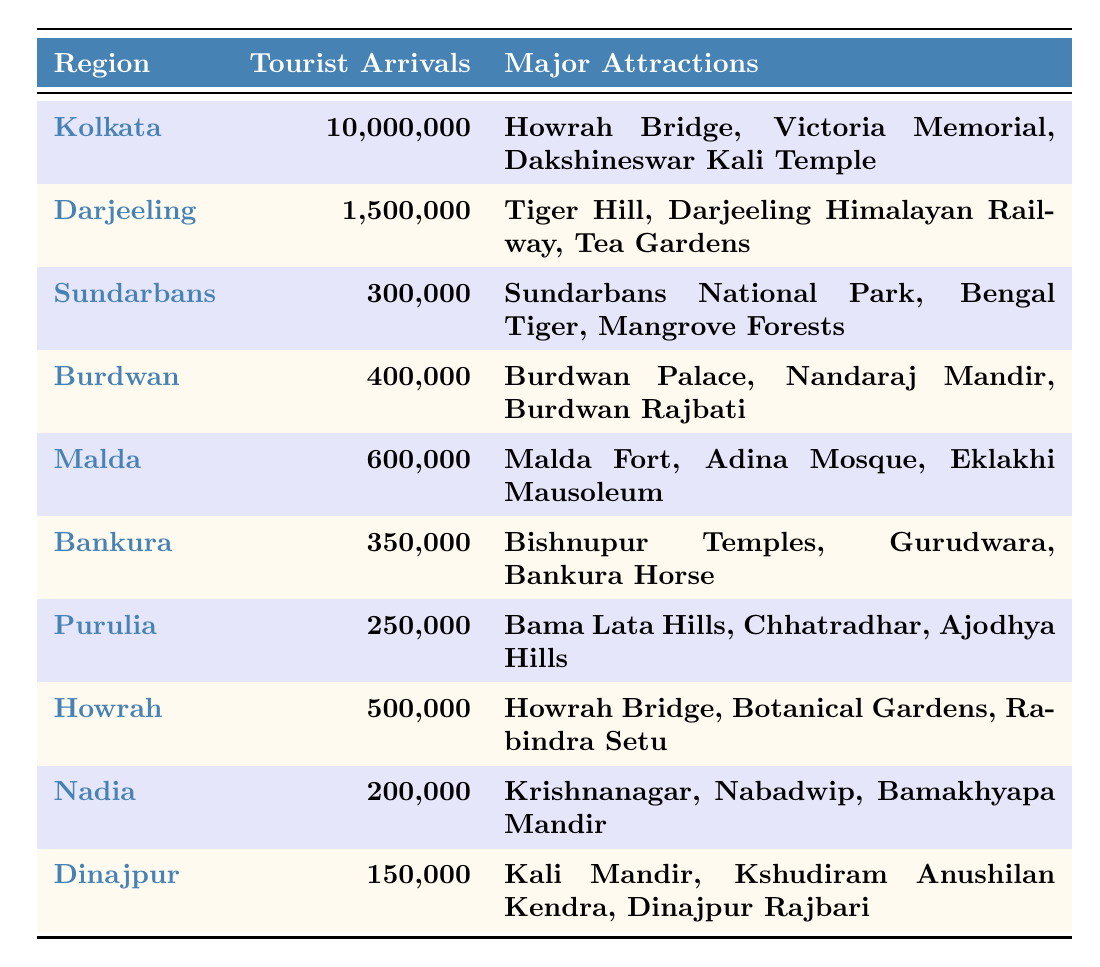What is the total number of tourist arrivals in West Bengal for 2022? To find the total, we need to add all the tourist arrivals from each region: 10,000,000 (Kolkata) + 1,500,000 (Darjeeling) + 300,000 (Sundarbans) + 400,000 (Burdwan) + 600,000 (Malda) + 350,000 (Bankura) + 250,000 (Purulia) + 500,000 (Howrah) + 200,000 (Nadia) + 150,000 (Dinajpur) = 13,451,000
Answer: 13,451,000 Which region received the least number of tourist arrivals? By scanning the "Tourist Arrivals" column, we see that Dinajpur has the lowest value, with 150,000 arrivals.
Answer: Dinajpur What is the difference in tourist arrivals between Kolkata and Sundarbans? The tourist arrivals for Kolkata are 10,000,000, and for Sundarbans, they are 300,000. The difference is calculated as 10,000,000 - 300,000 = 9,700,000.
Answer: 9,700,000 How many major attractions does the Darjeeling region have? The Darjeeling region lists three major attractions: Tiger Hill, Darjeeling Himalayan Railway, and Tea Gardens.
Answer: 3 What is the average number of tourist arrivals for the regions listed, excluding Kolkata? First, we count the number of regions excluding Kolkata, which are Darjeeling, Sundarbans, Burdwan, Malda, Bankura, Purulia, Howrah, Nadia, and Dinajpur (totaling 9 regions). Then we add their tourist arrivals: 1,500,000 + 300,000 + 400,000 + 600,000 + 350,000 + 250,000 + 500,000 + 200,000 + 150,000 = 3,250,000. Dividing this by 9 gives an average of 3,250,000 / 9 ≈ 361,111.
Answer: 361,111 Is it true that Howrah has more tourist arrivals than Burdwan? The table shows Howrah has 500,000 tourist arrivals and Burdwan has 400,000. Since 500,000 > 400,000, the statement is true.
Answer: Yes If we categorize tourist arrivals into 'high' (greater than 1 million) and 'low' (1 million or less), how many regions fall into each category? Looking at the table, Kolkata is the only region with more than 1 million arrivals (10,000,000). All other regions have 1 million or less. Thus, high = 1 region (Kolkata) and low = 9 regions (the rest).
Answer: High: 1, Low: 9 Which two regions have tourist arrivals closest in number? By examining the arrivals, Burdwan (400,000) and Malda (600,000) have the closest numbers; the difference is 600,000 - 400,000 = 200,000. The next closest pair is Bankura (350,000) and Purulia (250,000) with a difference of 100,000. Thus, Burdwan and Malda are not the closest; instead, Bankura and Purulia (350,000 and 250,000) are the closest in numbers.
Answer: Bankura and Purulia What is the total number of major attractions listed for the regions with more than 1 million tourist arrivals? The only region with more than 1 million tourist arrivals is Kolkata. It has 3 major attractions: Howrah Bridge, Victoria Memorial, and Dakshineswar Kali Temple. Since there's only one region, the total is just the count of its attractions.
Answer: 3 